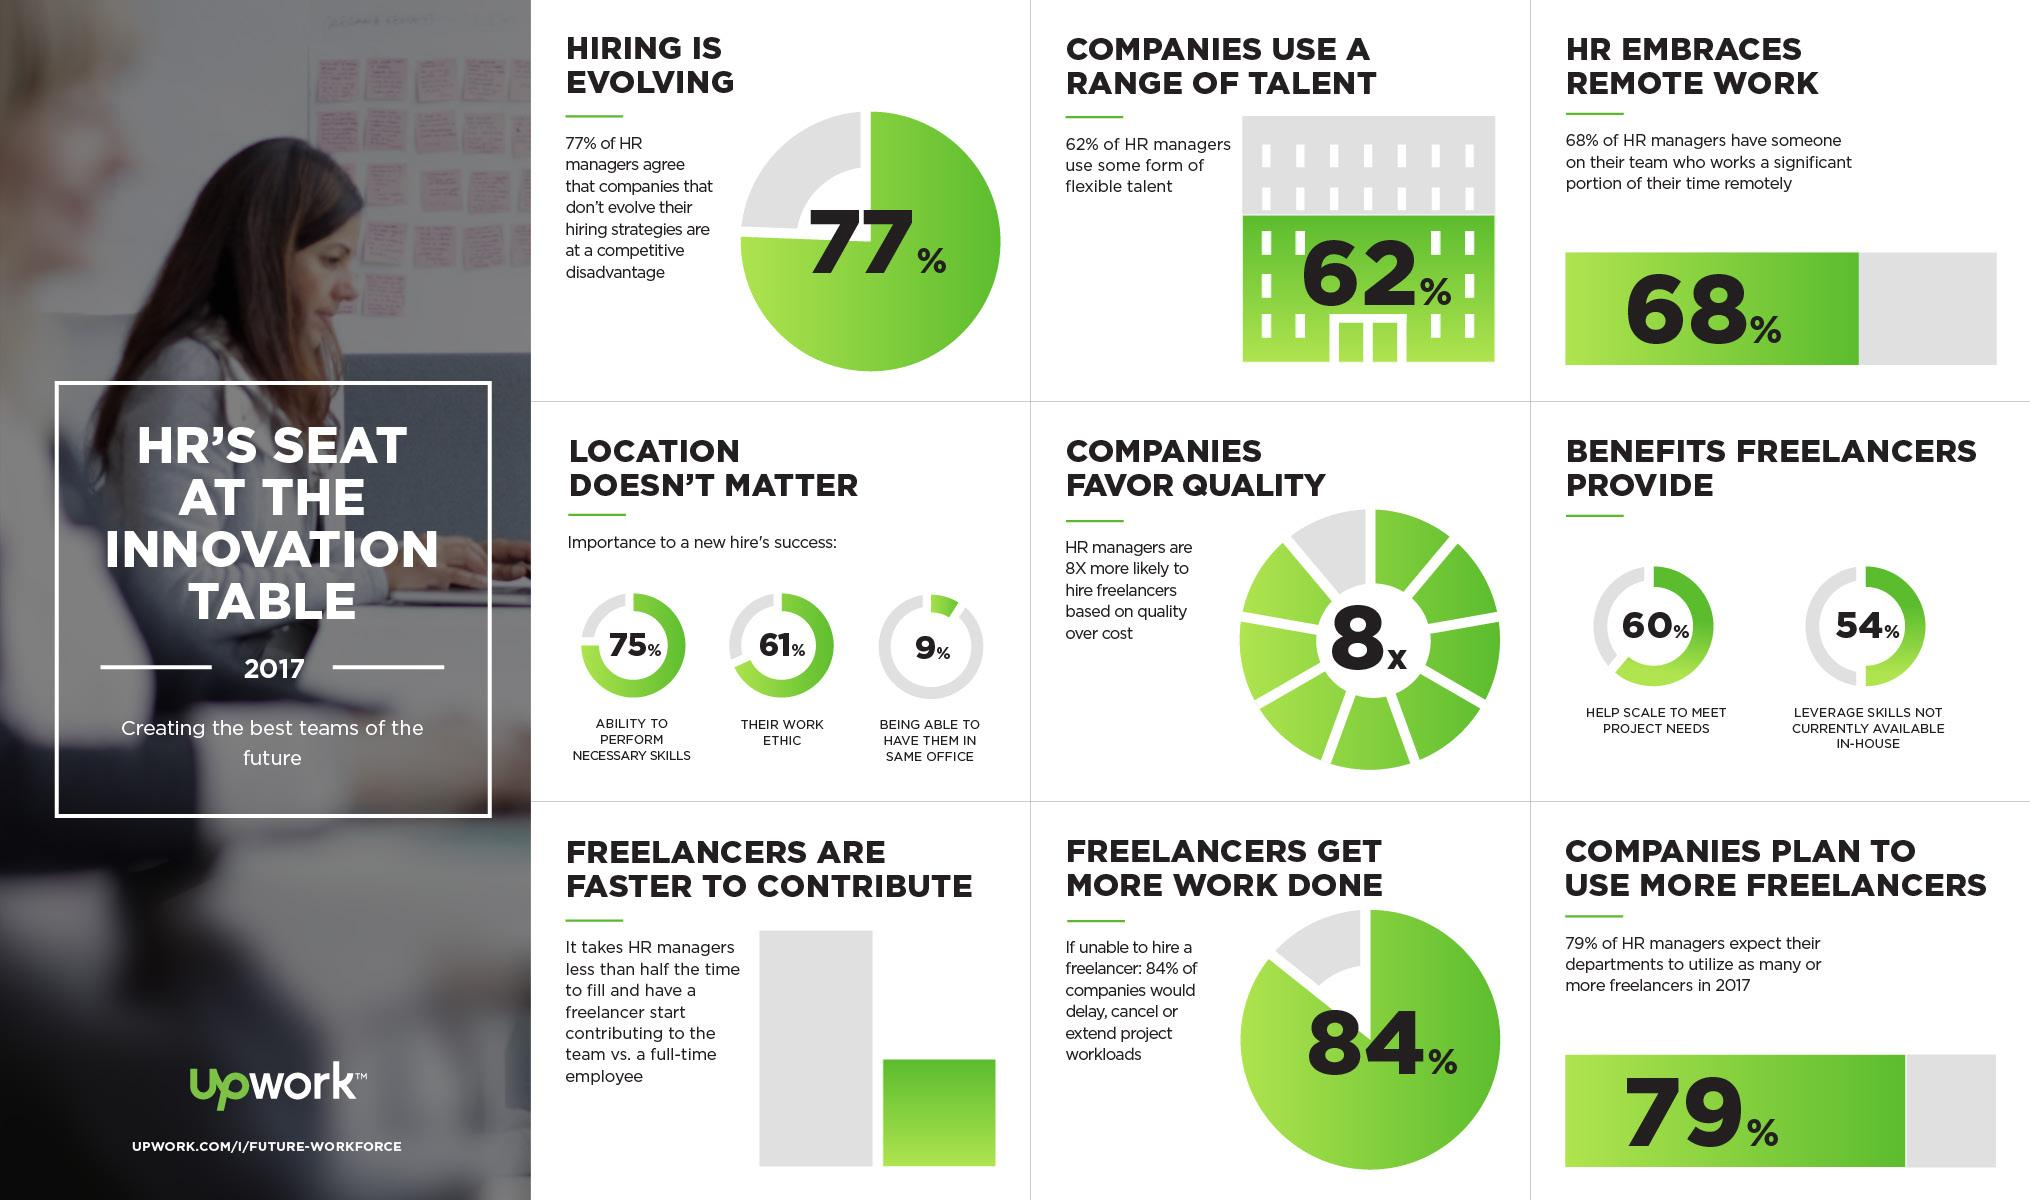Outline some significant characteristics in this image. According to data, 16% of companies do not cancel or extend their project if unable to hire a freelancer. In 2017, 21% of companies did not plan to use more freelancers, indicating that they were not considering the use of freelance workers for their business operations. 